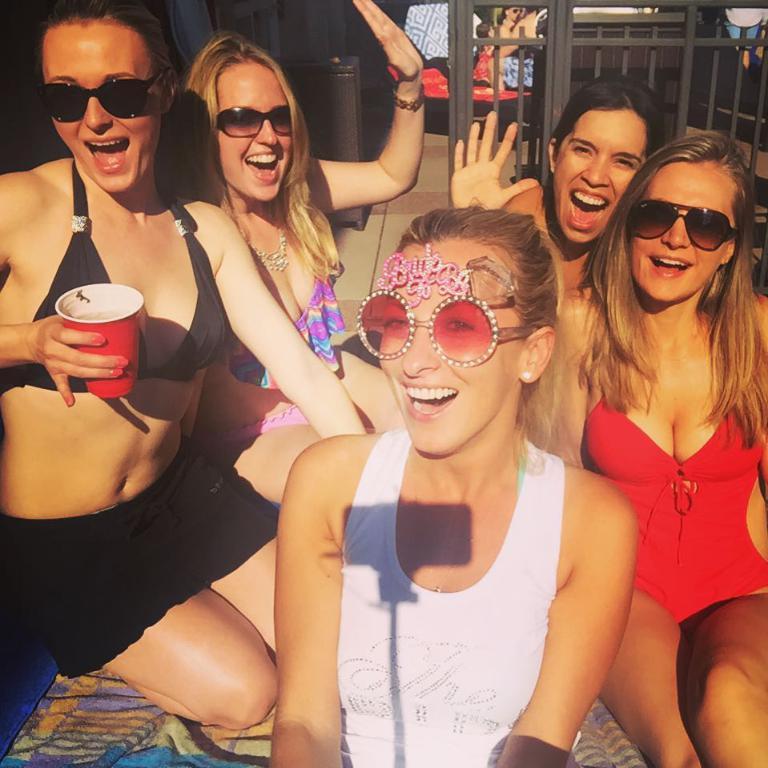Could you give a brief overview of what you see in this image? In this image there are persons sitting and smiling. In the front there is a woman kneeling and holding a glass in her hand and smiling. In the background there is a wooden fence and behind the fence there are persons and there are objects. On the left side there is a wooden stand which is visible. 